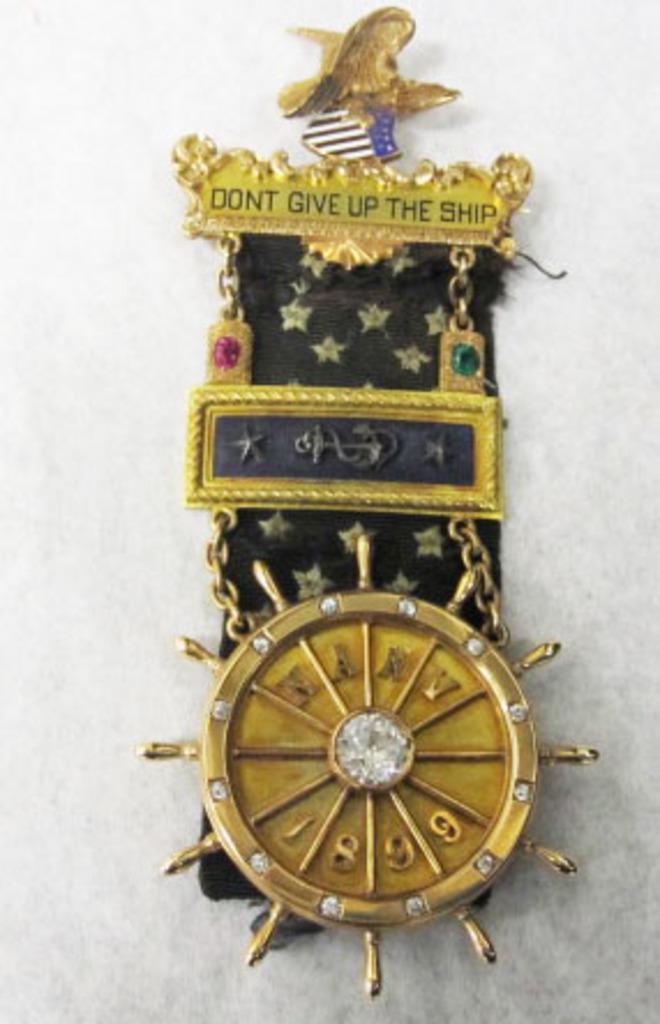What does it say to not give up?
Provide a short and direct response. The ship. What year is on this?
Your response must be concise. 1899. 